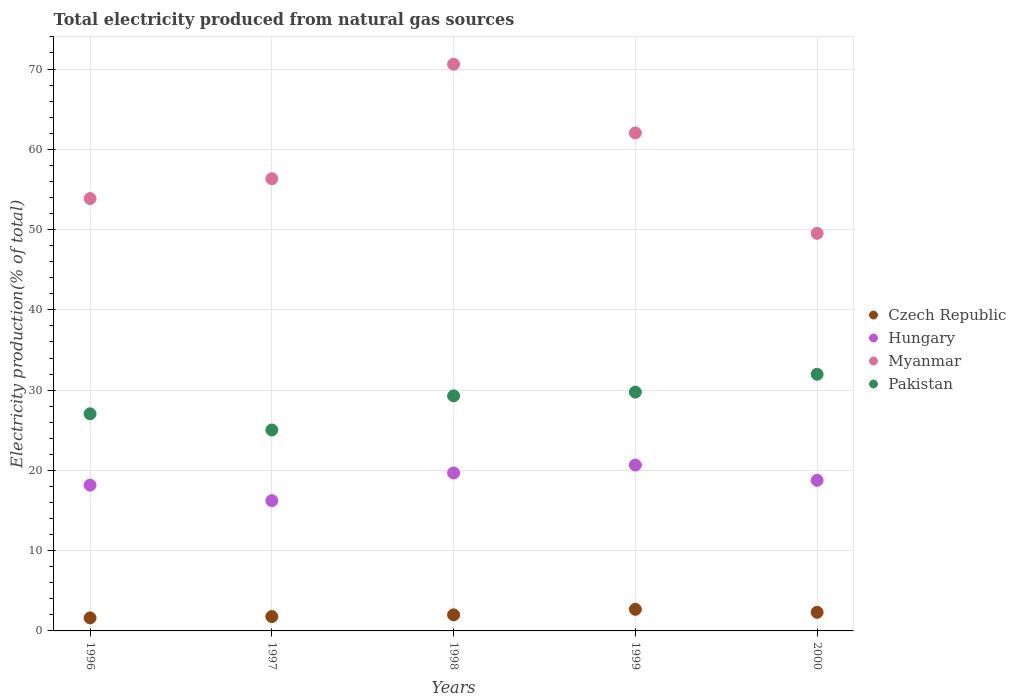How many different coloured dotlines are there?
Your answer should be compact. 4. What is the total electricity produced in Myanmar in 1998?
Give a very brief answer. 70.6. Across all years, what is the maximum total electricity produced in Myanmar?
Make the answer very short. 70.6. Across all years, what is the minimum total electricity produced in Myanmar?
Offer a very short reply. 49.53. In which year was the total electricity produced in Czech Republic maximum?
Give a very brief answer. 1999. In which year was the total electricity produced in Czech Republic minimum?
Provide a succinct answer. 1996. What is the total total electricity produced in Pakistan in the graph?
Make the answer very short. 143.09. What is the difference between the total electricity produced in Hungary in 1997 and that in 1999?
Your answer should be very brief. -4.44. What is the difference between the total electricity produced in Pakistan in 1998 and the total electricity produced in Myanmar in 1999?
Offer a terse response. -32.75. What is the average total electricity produced in Myanmar per year?
Offer a very short reply. 58.47. In the year 1998, what is the difference between the total electricity produced in Czech Republic and total electricity produced in Hungary?
Your answer should be compact. -17.68. In how many years, is the total electricity produced in Czech Republic greater than 56 %?
Keep it short and to the point. 0. What is the ratio of the total electricity produced in Pakistan in 1998 to that in 1999?
Offer a very short reply. 0.98. What is the difference between the highest and the second highest total electricity produced in Myanmar?
Offer a very short reply. 8.56. What is the difference between the highest and the lowest total electricity produced in Hungary?
Offer a terse response. 4.44. In how many years, is the total electricity produced in Pakistan greater than the average total electricity produced in Pakistan taken over all years?
Offer a terse response. 3. Is it the case that in every year, the sum of the total electricity produced in Czech Republic and total electricity produced in Myanmar  is greater than the total electricity produced in Pakistan?
Your answer should be compact. Yes. How many dotlines are there?
Make the answer very short. 4. Are the values on the major ticks of Y-axis written in scientific E-notation?
Keep it short and to the point. No. Where does the legend appear in the graph?
Offer a very short reply. Center right. What is the title of the graph?
Provide a short and direct response. Total electricity produced from natural gas sources. What is the label or title of the Y-axis?
Give a very brief answer. Electricity production(% of total). What is the Electricity production(% of total) of Czech Republic in 1996?
Provide a succinct answer. 1.62. What is the Electricity production(% of total) in Hungary in 1996?
Ensure brevity in your answer.  18.16. What is the Electricity production(% of total) in Myanmar in 1996?
Offer a very short reply. 53.87. What is the Electricity production(% of total) of Pakistan in 1996?
Your response must be concise. 27.05. What is the Electricity production(% of total) in Czech Republic in 1997?
Offer a terse response. 1.79. What is the Electricity production(% of total) of Hungary in 1997?
Keep it short and to the point. 16.23. What is the Electricity production(% of total) of Myanmar in 1997?
Offer a terse response. 56.33. What is the Electricity production(% of total) in Pakistan in 1997?
Provide a succinct answer. 25.03. What is the Electricity production(% of total) of Czech Republic in 1998?
Your answer should be compact. 2. What is the Electricity production(% of total) in Hungary in 1998?
Offer a terse response. 19.68. What is the Electricity production(% of total) of Myanmar in 1998?
Your answer should be very brief. 70.6. What is the Electricity production(% of total) in Pakistan in 1998?
Ensure brevity in your answer.  29.29. What is the Electricity production(% of total) of Czech Republic in 1999?
Offer a very short reply. 2.69. What is the Electricity production(% of total) in Hungary in 1999?
Provide a short and direct response. 20.67. What is the Electricity production(% of total) in Myanmar in 1999?
Make the answer very short. 62.04. What is the Electricity production(% of total) of Pakistan in 1999?
Provide a short and direct response. 29.75. What is the Electricity production(% of total) in Czech Republic in 2000?
Offer a terse response. 2.32. What is the Electricity production(% of total) in Hungary in 2000?
Your response must be concise. 18.76. What is the Electricity production(% of total) of Myanmar in 2000?
Give a very brief answer. 49.53. What is the Electricity production(% of total) in Pakistan in 2000?
Make the answer very short. 31.97. Across all years, what is the maximum Electricity production(% of total) in Czech Republic?
Your response must be concise. 2.69. Across all years, what is the maximum Electricity production(% of total) of Hungary?
Your response must be concise. 20.67. Across all years, what is the maximum Electricity production(% of total) in Myanmar?
Ensure brevity in your answer.  70.6. Across all years, what is the maximum Electricity production(% of total) in Pakistan?
Your response must be concise. 31.97. Across all years, what is the minimum Electricity production(% of total) in Czech Republic?
Ensure brevity in your answer.  1.62. Across all years, what is the minimum Electricity production(% of total) of Hungary?
Provide a succinct answer. 16.23. Across all years, what is the minimum Electricity production(% of total) of Myanmar?
Offer a terse response. 49.53. Across all years, what is the minimum Electricity production(% of total) of Pakistan?
Give a very brief answer. 25.03. What is the total Electricity production(% of total) in Czech Republic in the graph?
Provide a short and direct response. 10.43. What is the total Electricity production(% of total) of Hungary in the graph?
Keep it short and to the point. 93.5. What is the total Electricity production(% of total) in Myanmar in the graph?
Your answer should be compact. 292.37. What is the total Electricity production(% of total) of Pakistan in the graph?
Your response must be concise. 143.09. What is the difference between the Electricity production(% of total) of Czech Republic in 1996 and that in 1997?
Your answer should be compact. -0.17. What is the difference between the Electricity production(% of total) of Hungary in 1996 and that in 1997?
Offer a very short reply. 1.93. What is the difference between the Electricity production(% of total) of Myanmar in 1996 and that in 1997?
Ensure brevity in your answer.  -2.47. What is the difference between the Electricity production(% of total) in Pakistan in 1996 and that in 1997?
Provide a short and direct response. 2.02. What is the difference between the Electricity production(% of total) in Czech Republic in 1996 and that in 1998?
Offer a very short reply. -0.38. What is the difference between the Electricity production(% of total) in Hungary in 1996 and that in 1998?
Make the answer very short. -1.52. What is the difference between the Electricity production(% of total) of Myanmar in 1996 and that in 1998?
Offer a terse response. -16.73. What is the difference between the Electricity production(% of total) in Pakistan in 1996 and that in 1998?
Give a very brief answer. -2.24. What is the difference between the Electricity production(% of total) in Czech Republic in 1996 and that in 1999?
Offer a terse response. -1.07. What is the difference between the Electricity production(% of total) of Hungary in 1996 and that in 1999?
Your response must be concise. -2.51. What is the difference between the Electricity production(% of total) of Myanmar in 1996 and that in 1999?
Give a very brief answer. -8.17. What is the difference between the Electricity production(% of total) in Pakistan in 1996 and that in 1999?
Offer a very short reply. -2.71. What is the difference between the Electricity production(% of total) in Czech Republic in 1996 and that in 2000?
Provide a succinct answer. -0.7. What is the difference between the Electricity production(% of total) of Hungary in 1996 and that in 2000?
Provide a succinct answer. -0.6. What is the difference between the Electricity production(% of total) of Myanmar in 1996 and that in 2000?
Offer a terse response. 4.33. What is the difference between the Electricity production(% of total) in Pakistan in 1996 and that in 2000?
Offer a very short reply. -4.93. What is the difference between the Electricity production(% of total) in Czech Republic in 1997 and that in 1998?
Offer a very short reply. -0.21. What is the difference between the Electricity production(% of total) of Hungary in 1997 and that in 1998?
Give a very brief answer. -3.45. What is the difference between the Electricity production(% of total) of Myanmar in 1997 and that in 1998?
Your response must be concise. -14.26. What is the difference between the Electricity production(% of total) of Pakistan in 1997 and that in 1998?
Keep it short and to the point. -4.25. What is the difference between the Electricity production(% of total) of Czech Republic in 1997 and that in 1999?
Make the answer very short. -0.9. What is the difference between the Electricity production(% of total) in Hungary in 1997 and that in 1999?
Give a very brief answer. -4.44. What is the difference between the Electricity production(% of total) of Myanmar in 1997 and that in 1999?
Ensure brevity in your answer.  -5.71. What is the difference between the Electricity production(% of total) of Pakistan in 1997 and that in 1999?
Your answer should be compact. -4.72. What is the difference between the Electricity production(% of total) in Czech Republic in 1997 and that in 2000?
Provide a short and direct response. -0.53. What is the difference between the Electricity production(% of total) of Hungary in 1997 and that in 2000?
Make the answer very short. -2.53. What is the difference between the Electricity production(% of total) in Myanmar in 1997 and that in 2000?
Keep it short and to the point. 6.8. What is the difference between the Electricity production(% of total) in Pakistan in 1997 and that in 2000?
Your response must be concise. -6.94. What is the difference between the Electricity production(% of total) in Czech Republic in 1998 and that in 1999?
Provide a succinct answer. -0.69. What is the difference between the Electricity production(% of total) of Hungary in 1998 and that in 1999?
Provide a succinct answer. -0.99. What is the difference between the Electricity production(% of total) in Myanmar in 1998 and that in 1999?
Provide a short and direct response. 8.56. What is the difference between the Electricity production(% of total) of Pakistan in 1998 and that in 1999?
Provide a short and direct response. -0.47. What is the difference between the Electricity production(% of total) of Czech Republic in 1998 and that in 2000?
Your response must be concise. -0.32. What is the difference between the Electricity production(% of total) of Hungary in 1998 and that in 2000?
Your response must be concise. 0.92. What is the difference between the Electricity production(% of total) of Myanmar in 1998 and that in 2000?
Provide a succinct answer. 21.07. What is the difference between the Electricity production(% of total) in Pakistan in 1998 and that in 2000?
Keep it short and to the point. -2.69. What is the difference between the Electricity production(% of total) of Czech Republic in 1999 and that in 2000?
Ensure brevity in your answer.  0.37. What is the difference between the Electricity production(% of total) of Hungary in 1999 and that in 2000?
Your response must be concise. 1.91. What is the difference between the Electricity production(% of total) in Myanmar in 1999 and that in 2000?
Make the answer very short. 12.51. What is the difference between the Electricity production(% of total) of Pakistan in 1999 and that in 2000?
Your answer should be compact. -2.22. What is the difference between the Electricity production(% of total) in Czech Republic in 1996 and the Electricity production(% of total) in Hungary in 1997?
Ensure brevity in your answer.  -14.61. What is the difference between the Electricity production(% of total) in Czech Republic in 1996 and the Electricity production(% of total) in Myanmar in 1997?
Your answer should be compact. -54.71. What is the difference between the Electricity production(% of total) in Czech Republic in 1996 and the Electricity production(% of total) in Pakistan in 1997?
Give a very brief answer. -23.41. What is the difference between the Electricity production(% of total) in Hungary in 1996 and the Electricity production(% of total) in Myanmar in 1997?
Offer a terse response. -38.17. What is the difference between the Electricity production(% of total) of Hungary in 1996 and the Electricity production(% of total) of Pakistan in 1997?
Give a very brief answer. -6.87. What is the difference between the Electricity production(% of total) of Myanmar in 1996 and the Electricity production(% of total) of Pakistan in 1997?
Give a very brief answer. 28.83. What is the difference between the Electricity production(% of total) in Czech Republic in 1996 and the Electricity production(% of total) in Hungary in 1998?
Offer a very short reply. -18.06. What is the difference between the Electricity production(% of total) of Czech Republic in 1996 and the Electricity production(% of total) of Myanmar in 1998?
Offer a terse response. -68.97. What is the difference between the Electricity production(% of total) in Czech Republic in 1996 and the Electricity production(% of total) in Pakistan in 1998?
Your answer should be compact. -27.66. What is the difference between the Electricity production(% of total) of Hungary in 1996 and the Electricity production(% of total) of Myanmar in 1998?
Make the answer very short. -52.43. What is the difference between the Electricity production(% of total) in Hungary in 1996 and the Electricity production(% of total) in Pakistan in 1998?
Make the answer very short. -11.12. What is the difference between the Electricity production(% of total) in Myanmar in 1996 and the Electricity production(% of total) in Pakistan in 1998?
Give a very brief answer. 24.58. What is the difference between the Electricity production(% of total) in Czech Republic in 1996 and the Electricity production(% of total) in Hungary in 1999?
Your answer should be compact. -19.05. What is the difference between the Electricity production(% of total) in Czech Republic in 1996 and the Electricity production(% of total) in Myanmar in 1999?
Offer a terse response. -60.42. What is the difference between the Electricity production(% of total) in Czech Republic in 1996 and the Electricity production(% of total) in Pakistan in 1999?
Your response must be concise. -28.13. What is the difference between the Electricity production(% of total) in Hungary in 1996 and the Electricity production(% of total) in Myanmar in 1999?
Keep it short and to the point. -43.88. What is the difference between the Electricity production(% of total) of Hungary in 1996 and the Electricity production(% of total) of Pakistan in 1999?
Your answer should be compact. -11.59. What is the difference between the Electricity production(% of total) in Myanmar in 1996 and the Electricity production(% of total) in Pakistan in 1999?
Offer a very short reply. 24.11. What is the difference between the Electricity production(% of total) of Czech Republic in 1996 and the Electricity production(% of total) of Hungary in 2000?
Ensure brevity in your answer.  -17.14. What is the difference between the Electricity production(% of total) in Czech Republic in 1996 and the Electricity production(% of total) in Myanmar in 2000?
Ensure brevity in your answer.  -47.91. What is the difference between the Electricity production(% of total) in Czech Republic in 1996 and the Electricity production(% of total) in Pakistan in 2000?
Your answer should be compact. -30.35. What is the difference between the Electricity production(% of total) of Hungary in 1996 and the Electricity production(% of total) of Myanmar in 2000?
Provide a short and direct response. -31.37. What is the difference between the Electricity production(% of total) in Hungary in 1996 and the Electricity production(% of total) in Pakistan in 2000?
Give a very brief answer. -13.81. What is the difference between the Electricity production(% of total) of Myanmar in 1996 and the Electricity production(% of total) of Pakistan in 2000?
Provide a succinct answer. 21.89. What is the difference between the Electricity production(% of total) of Czech Republic in 1997 and the Electricity production(% of total) of Hungary in 1998?
Keep it short and to the point. -17.89. What is the difference between the Electricity production(% of total) of Czech Republic in 1997 and the Electricity production(% of total) of Myanmar in 1998?
Provide a short and direct response. -68.8. What is the difference between the Electricity production(% of total) in Czech Republic in 1997 and the Electricity production(% of total) in Pakistan in 1998?
Provide a short and direct response. -27.49. What is the difference between the Electricity production(% of total) in Hungary in 1997 and the Electricity production(% of total) in Myanmar in 1998?
Give a very brief answer. -54.37. What is the difference between the Electricity production(% of total) in Hungary in 1997 and the Electricity production(% of total) in Pakistan in 1998?
Provide a short and direct response. -13.06. What is the difference between the Electricity production(% of total) in Myanmar in 1997 and the Electricity production(% of total) in Pakistan in 1998?
Keep it short and to the point. 27.05. What is the difference between the Electricity production(% of total) in Czech Republic in 1997 and the Electricity production(% of total) in Hungary in 1999?
Ensure brevity in your answer.  -18.88. What is the difference between the Electricity production(% of total) in Czech Republic in 1997 and the Electricity production(% of total) in Myanmar in 1999?
Give a very brief answer. -60.25. What is the difference between the Electricity production(% of total) in Czech Republic in 1997 and the Electricity production(% of total) in Pakistan in 1999?
Provide a succinct answer. -27.96. What is the difference between the Electricity production(% of total) in Hungary in 1997 and the Electricity production(% of total) in Myanmar in 1999?
Your answer should be very brief. -45.81. What is the difference between the Electricity production(% of total) of Hungary in 1997 and the Electricity production(% of total) of Pakistan in 1999?
Your answer should be very brief. -13.52. What is the difference between the Electricity production(% of total) in Myanmar in 1997 and the Electricity production(% of total) in Pakistan in 1999?
Your answer should be compact. 26.58. What is the difference between the Electricity production(% of total) in Czech Republic in 1997 and the Electricity production(% of total) in Hungary in 2000?
Your answer should be very brief. -16.97. What is the difference between the Electricity production(% of total) in Czech Republic in 1997 and the Electricity production(% of total) in Myanmar in 2000?
Ensure brevity in your answer.  -47.74. What is the difference between the Electricity production(% of total) of Czech Republic in 1997 and the Electricity production(% of total) of Pakistan in 2000?
Offer a terse response. -30.18. What is the difference between the Electricity production(% of total) in Hungary in 1997 and the Electricity production(% of total) in Myanmar in 2000?
Provide a succinct answer. -33.3. What is the difference between the Electricity production(% of total) in Hungary in 1997 and the Electricity production(% of total) in Pakistan in 2000?
Keep it short and to the point. -15.74. What is the difference between the Electricity production(% of total) in Myanmar in 1997 and the Electricity production(% of total) in Pakistan in 2000?
Ensure brevity in your answer.  24.36. What is the difference between the Electricity production(% of total) in Czech Republic in 1998 and the Electricity production(% of total) in Hungary in 1999?
Offer a terse response. -18.67. What is the difference between the Electricity production(% of total) of Czech Republic in 1998 and the Electricity production(% of total) of Myanmar in 1999?
Make the answer very short. -60.04. What is the difference between the Electricity production(% of total) in Czech Republic in 1998 and the Electricity production(% of total) in Pakistan in 1999?
Provide a succinct answer. -27.75. What is the difference between the Electricity production(% of total) in Hungary in 1998 and the Electricity production(% of total) in Myanmar in 1999?
Provide a short and direct response. -42.36. What is the difference between the Electricity production(% of total) in Hungary in 1998 and the Electricity production(% of total) in Pakistan in 1999?
Provide a succinct answer. -10.07. What is the difference between the Electricity production(% of total) in Myanmar in 1998 and the Electricity production(% of total) in Pakistan in 1999?
Provide a succinct answer. 40.84. What is the difference between the Electricity production(% of total) of Czech Republic in 1998 and the Electricity production(% of total) of Hungary in 2000?
Offer a terse response. -16.76. What is the difference between the Electricity production(% of total) in Czech Republic in 1998 and the Electricity production(% of total) in Myanmar in 2000?
Provide a short and direct response. -47.53. What is the difference between the Electricity production(% of total) in Czech Republic in 1998 and the Electricity production(% of total) in Pakistan in 2000?
Offer a very short reply. -29.97. What is the difference between the Electricity production(% of total) of Hungary in 1998 and the Electricity production(% of total) of Myanmar in 2000?
Provide a succinct answer. -29.85. What is the difference between the Electricity production(% of total) in Hungary in 1998 and the Electricity production(% of total) in Pakistan in 2000?
Give a very brief answer. -12.29. What is the difference between the Electricity production(% of total) in Myanmar in 1998 and the Electricity production(% of total) in Pakistan in 2000?
Offer a very short reply. 38.62. What is the difference between the Electricity production(% of total) in Czech Republic in 1999 and the Electricity production(% of total) in Hungary in 2000?
Your answer should be compact. -16.07. What is the difference between the Electricity production(% of total) of Czech Republic in 1999 and the Electricity production(% of total) of Myanmar in 2000?
Offer a very short reply. -46.84. What is the difference between the Electricity production(% of total) of Czech Republic in 1999 and the Electricity production(% of total) of Pakistan in 2000?
Your response must be concise. -29.28. What is the difference between the Electricity production(% of total) in Hungary in 1999 and the Electricity production(% of total) in Myanmar in 2000?
Offer a terse response. -28.86. What is the difference between the Electricity production(% of total) in Hungary in 1999 and the Electricity production(% of total) in Pakistan in 2000?
Your response must be concise. -11.3. What is the difference between the Electricity production(% of total) of Myanmar in 1999 and the Electricity production(% of total) of Pakistan in 2000?
Offer a terse response. 30.06. What is the average Electricity production(% of total) in Czech Republic per year?
Provide a succinct answer. 2.09. What is the average Electricity production(% of total) of Hungary per year?
Your answer should be compact. 18.7. What is the average Electricity production(% of total) in Myanmar per year?
Your answer should be very brief. 58.47. What is the average Electricity production(% of total) of Pakistan per year?
Offer a terse response. 28.62. In the year 1996, what is the difference between the Electricity production(% of total) of Czech Republic and Electricity production(% of total) of Hungary?
Provide a succinct answer. -16.54. In the year 1996, what is the difference between the Electricity production(% of total) in Czech Republic and Electricity production(% of total) in Myanmar?
Keep it short and to the point. -52.24. In the year 1996, what is the difference between the Electricity production(% of total) in Czech Republic and Electricity production(% of total) in Pakistan?
Give a very brief answer. -25.42. In the year 1996, what is the difference between the Electricity production(% of total) in Hungary and Electricity production(% of total) in Myanmar?
Keep it short and to the point. -35.7. In the year 1996, what is the difference between the Electricity production(% of total) of Hungary and Electricity production(% of total) of Pakistan?
Keep it short and to the point. -8.89. In the year 1996, what is the difference between the Electricity production(% of total) of Myanmar and Electricity production(% of total) of Pakistan?
Provide a short and direct response. 26.82. In the year 1997, what is the difference between the Electricity production(% of total) in Czech Republic and Electricity production(% of total) in Hungary?
Make the answer very short. -14.44. In the year 1997, what is the difference between the Electricity production(% of total) of Czech Republic and Electricity production(% of total) of Myanmar?
Keep it short and to the point. -54.54. In the year 1997, what is the difference between the Electricity production(% of total) of Czech Republic and Electricity production(% of total) of Pakistan?
Your answer should be very brief. -23.24. In the year 1997, what is the difference between the Electricity production(% of total) in Hungary and Electricity production(% of total) in Myanmar?
Offer a very short reply. -40.1. In the year 1997, what is the difference between the Electricity production(% of total) of Hungary and Electricity production(% of total) of Pakistan?
Provide a succinct answer. -8.8. In the year 1997, what is the difference between the Electricity production(% of total) of Myanmar and Electricity production(% of total) of Pakistan?
Give a very brief answer. 31.3. In the year 1998, what is the difference between the Electricity production(% of total) in Czech Republic and Electricity production(% of total) in Hungary?
Offer a terse response. -17.68. In the year 1998, what is the difference between the Electricity production(% of total) in Czech Republic and Electricity production(% of total) in Myanmar?
Your answer should be very brief. -68.59. In the year 1998, what is the difference between the Electricity production(% of total) in Czech Republic and Electricity production(% of total) in Pakistan?
Keep it short and to the point. -27.28. In the year 1998, what is the difference between the Electricity production(% of total) in Hungary and Electricity production(% of total) in Myanmar?
Offer a very short reply. -50.92. In the year 1998, what is the difference between the Electricity production(% of total) in Hungary and Electricity production(% of total) in Pakistan?
Keep it short and to the point. -9.61. In the year 1998, what is the difference between the Electricity production(% of total) in Myanmar and Electricity production(% of total) in Pakistan?
Keep it short and to the point. 41.31. In the year 1999, what is the difference between the Electricity production(% of total) of Czech Republic and Electricity production(% of total) of Hungary?
Give a very brief answer. -17.98. In the year 1999, what is the difference between the Electricity production(% of total) in Czech Republic and Electricity production(% of total) in Myanmar?
Keep it short and to the point. -59.35. In the year 1999, what is the difference between the Electricity production(% of total) of Czech Republic and Electricity production(% of total) of Pakistan?
Make the answer very short. -27.06. In the year 1999, what is the difference between the Electricity production(% of total) of Hungary and Electricity production(% of total) of Myanmar?
Your response must be concise. -41.37. In the year 1999, what is the difference between the Electricity production(% of total) in Hungary and Electricity production(% of total) in Pakistan?
Keep it short and to the point. -9.08. In the year 1999, what is the difference between the Electricity production(% of total) in Myanmar and Electricity production(% of total) in Pakistan?
Offer a terse response. 32.29. In the year 2000, what is the difference between the Electricity production(% of total) of Czech Republic and Electricity production(% of total) of Hungary?
Provide a short and direct response. -16.44. In the year 2000, what is the difference between the Electricity production(% of total) in Czech Republic and Electricity production(% of total) in Myanmar?
Your answer should be very brief. -47.21. In the year 2000, what is the difference between the Electricity production(% of total) of Czech Republic and Electricity production(% of total) of Pakistan?
Your answer should be very brief. -29.66. In the year 2000, what is the difference between the Electricity production(% of total) in Hungary and Electricity production(% of total) in Myanmar?
Make the answer very short. -30.77. In the year 2000, what is the difference between the Electricity production(% of total) in Hungary and Electricity production(% of total) in Pakistan?
Give a very brief answer. -13.21. In the year 2000, what is the difference between the Electricity production(% of total) of Myanmar and Electricity production(% of total) of Pakistan?
Offer a very short reply. 17.56. What is the ratio of the Electricity production(% of total) of Czech Republic in 1996 to that in 1997?
Provide a short and direct response. 0.91. What is the ratio of the Electricity production(% of total) of Hungary in 1996 to that in 1997?
Make the answer very short. 1.12. What is the ratio of the Electricity production(% of total) in Myanmar in 1996 to that in 1997?
Keep it short and to the point. 0.96. What is the ratio of the Electricity production(% of total) of Pakistan in 1996 to that in 1997?
Give a very brief answer. 1.08. What is the ratio of the Electricity production(% of total) of Czech Republic in 1996 to that in 1998?
Your answer should be very brief. 0.81. What is the ratio of the Electricity production(% of total) of Hungary in 1996 to that in 1998?
Your response must be concise. 0.92. What is the ratio of the Electricity production(% of total) of Myanmar in 1996 to that in 1998?
Your response must be concise. 0.76. What is the ratio of the Electricity production(% of total) of Pakistan in 1996 to that in 1998?
Give a very brief answer. 0.92. What is the ratio of the Electricity production(% of total) of Czech Republic in 1996 to that in 1999?
Keep it short and to the point. 0.6. What is the ratio of the Electricity production(% of total) in Hungary in 1996 to that in 1999?
Offer a terse response. 0.88. What is the ratio of the Electricity production(% of total) in Myanmar in 1996 to that in 1999?
Offer a very short reply. 0.87. What is the ratio of the Electricity production(% of total) in Pakistan in 1996 to that in 1999?
Offer a terse response. 0.91. What is the ratio of the Electricity production(% of total) of Czech Republic in 1996 to that in 2000?
Your response must be concise. 0.7. What is the ratio of the Electricity production(% of total) of Hungary in 1996 to that in 2000?
Keep it short and to the point. 0.97. What is the ratio of the Electricity production(% of total) of Myanmar in 1996 to that in 2000?
Offer a terse response. 1.09. What is the ratio of the Electricity production(% of total) of Pakistan in 1996 to that in 2000?
Give a very brief answer. 0.85. What is the ratio of the Electricity production(% of total) in Czech Republic in 1997 to that in 1998?
Give a very brief answer. 0.9. What is the ratio of the Electricity production(% of total) of Hungary in 1997 to that in 1998?
Your response must be concise. 0.82. What is the ratio of the Electricity production(% of total) of Myanmar in 1997 to that in 1998?
Your answer should be compact. 0.8. What is the ratio of the Electricity production(% of total) in Pakistan in 1997 to that in 1998?
Ensure brevity in your answer.  0.85. What is the ratio of the Electricity production(% of total) of Czech Republic in 1997 to that in 1999?
Offer a terse response. 0.67. What is the ratio of the Electricity production(% of total) in Hungary in 1997 to that in 1999?
Your answer should be very brief. 0.79. What is the ratio of the Electricity production(% of total) in Myanmar in 1997 to that in 1999?
Ensure brevity in your answer.  0.91. What is the ratio of the Electricity production(% of total) in Pakistan in 1997 to that in 1999?
Offer a very short reply. 0.84. What is the ratio of the Electricity production(% of total) of Czech Republic in 1997 to that in 2000?
Offer a terse response. 0.77. What is the ratio of the Electricity production(% of total) in Hungary in 1997 to that in 2000?
Provide a succinct answer. 0.87. What is the ratio of the Electricity production(% of total) of Myanmar in 1997 to that in 2000?
Provide a succinct answer. 1.14. What is the ratio of the Electricity production(% of total) in Pakistan in 1997 to that in 2000?
Provide a short and direct response. 0.78. What is the ratio of the Electricity production(% of total) in Czech Republic in 1998 to that in 1999?
Your answer should be compact. 0.74. What is the ratio of the Electricity production(% of total) in Hungary in 1998 to that in 1999?
Keep it short and to the point. 0.95. What is the ratio of the Electricity production(% of total) of Myanmar in 1998 to that in 1999?
Ensure brevity in your answer.  1.14. What is the ratio of the Electricity production(% of total) in Pakistan in 1998 to that in 1999?
Provide a short and direct response. 0.98. What is the ratio of the Electricity production(% of total) of Czech Republic in 1998 to that in 2000?
Offer a terse response. 0.86. What is the ratio of the Electricity production(% of total) in Hungary in 1998 to that in 2000?
Provide a succinct answer. 1.05. What is the ratio of the Electricity production(% of total) of Myanmar in 1998 to that in 2000?
Provide a short and direct response. 1.43. What is the ratio of the Electricity production(% of total) in Pakistan in 1998 to that in 2000?
Your answer should be compact. 0.92. What is the ratio of the Electricity production(% of total) of Czech Republic in 1999 to that in 2000?
Offer a terse response. 1.16. What is the ratio of the Electricity production(% of total) in Hungary in 1999 to that in 2000?
Your answer should be compact. 1.1. What is the ratio of the Electricity production(% of total) of Myanmar in 1999 to that in 2000?
Your answer should be very brief. 1.25. What is the ratio of the Electricity production(% of total) of Pakistan in 1999 to that in 2000?
Ensure brevity in your answer.  0.93. What is the difference between the highest and the second highest Electricity production(% of total) in Czech Republic?
Ensure brevity in your answer.  0.37. What is the difference between the highest and the second highest Electricity production(% of total) of Hungary?
Provide a succinct answer. 0.99. What is the difference between the highest and the second highest Electricity production(% of total) of Myanmar?
Offer a very short reply. 8.56. What is the difference between the highest and the second highest Electricity production(% of total) of Pakistan?
Provide a succinct answer. 2.22. What is the difference between the highest and the lowest Electricity production(% of total) of Czech Republic?
Provide a short and direct response. 1.07. What is the difference between the highest and the lowest Electricity production(% of total) of Hungary?
Ensure brevity in your answer.  4.44. What is the difference between the highest and the lowest Electricity production(% of total) in Myanmar?
Give a very brief answer. 21.07. What is the difference between the highest and the lowest Electricity production(% of total) in Pakistan?
Provide a short and direct response. 6.94. 